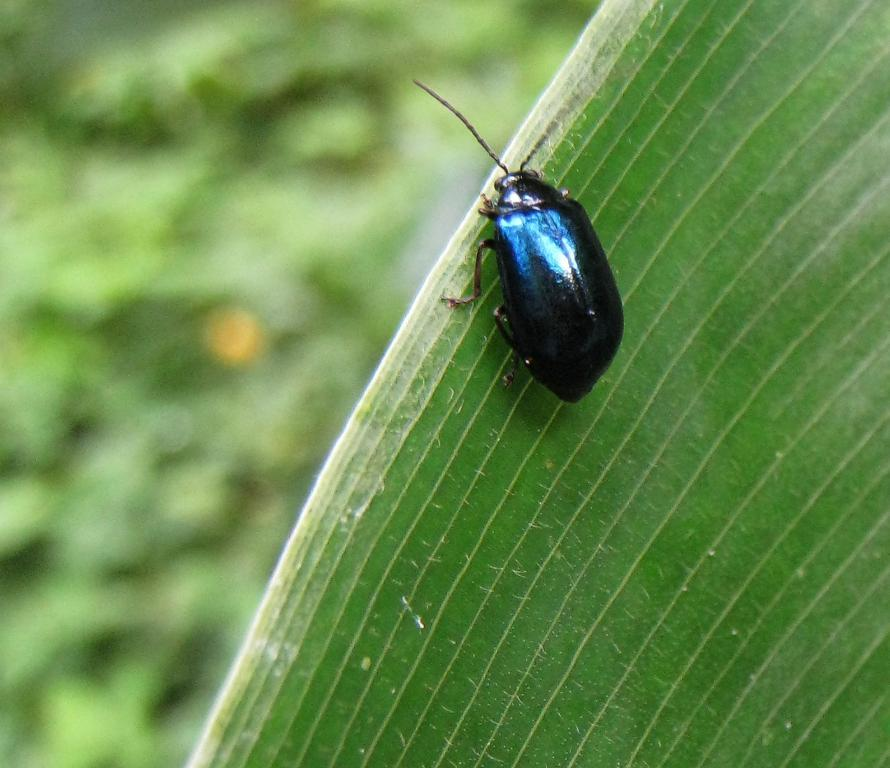What is present in the image? There is a bug in the image. Where is the bug located? The bug is on a leaf. What is the position of the bug and leaf in the image? The bug and leaf are in the center of the image. What type of locket is the hen wearing in the image? There is no hen or locket present in the image; it features a bug on a leaf. Can you describe the tiger's stripes in the image? There is no tiger present in the image; it features a bug on a leaf. 